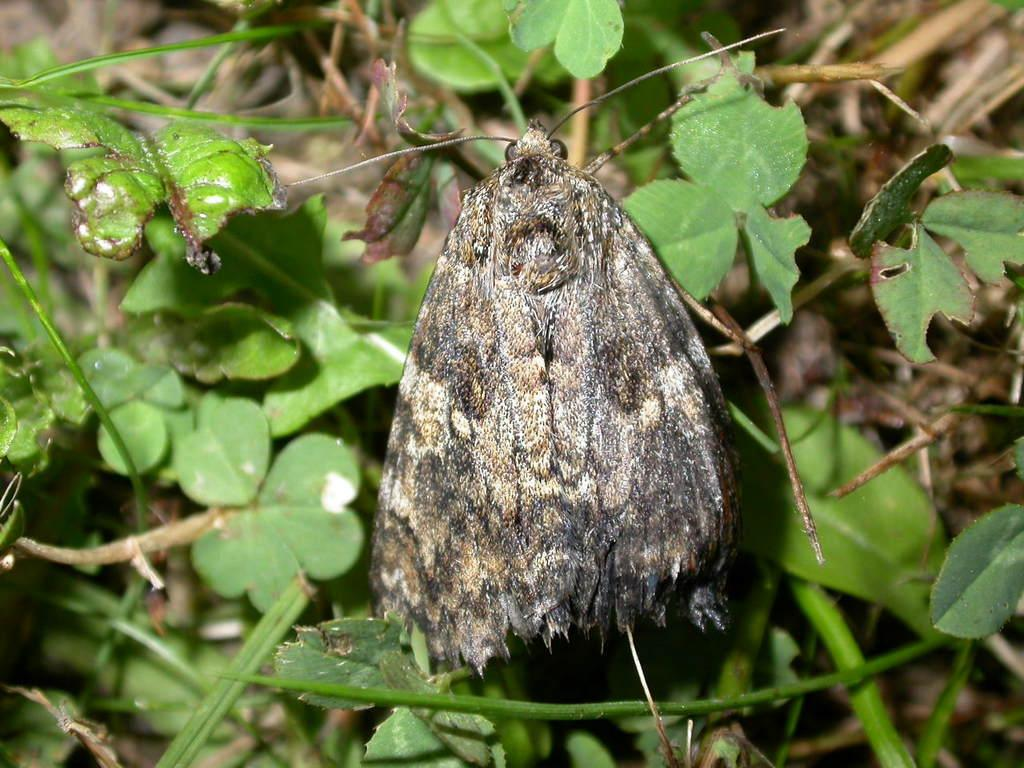What type of creature is in the image? There is a moth in the image. Where is the moth located in the image? The moth is standing on land in the image. What type of vegetation can be seen on the land? There is grass on the land in the image. What type of nut is the moth holding in its mouth in the image? There is no nut present in the image; the moth is standing on land with grass. 